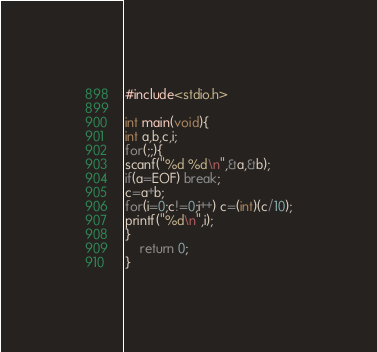Convert code to text. <code><loc_0><loc_0><loc_500><loc_500><_C_>#include<stdio.h>
 
int main(void){
int a,b,c,i;
for(;;){
scanf("%d %d\n",&a,&b);
if(a=EOF) break;
c=a+b;
for(i=0;c!=0;i++) c=(int)(c/10);
printf("%d\n",i);
}
    return 0;
}</code> 